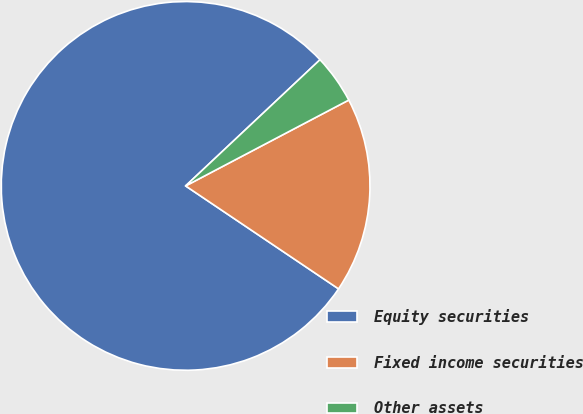Convert chart. <chart><loc_0><loc_0><loc_500><loc_500><pie_chart><fcel>Equity securities<fcel>Fixed income securities<fcel>Other assets<nl><fcel>78.57%<fcel>17.14%<fcel>4.29%<nl></chart> 